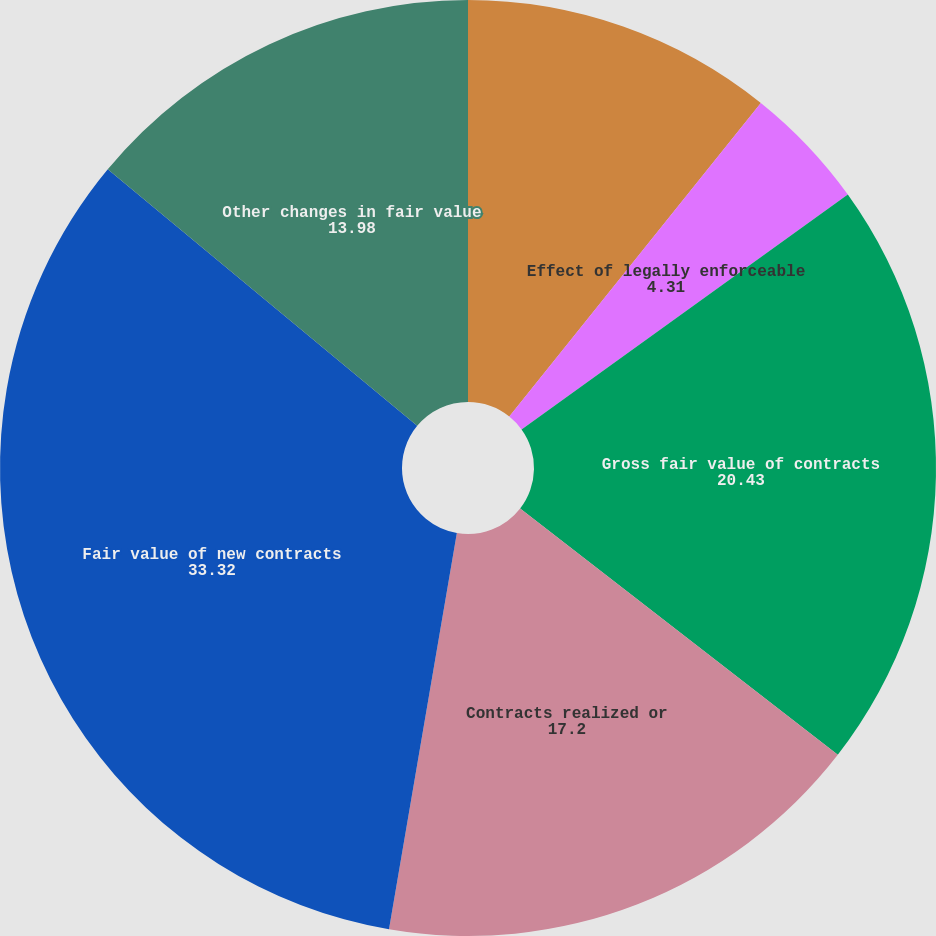Convert chart. <chart><loc_0><loc_0><loc_500><loc_500><pie_chart><fcel>Net fair value of contracts<fcel>Effect of legally enforceable<fcel>Gross fair value of contracts<fcel>Contracts realized or<fcel>Fair value of new contracts<fcel>Other changes in fair value<nl><fcel>10.76%<fcel>4.31%<fcel>20.43%<fcel>17.2%<fcel>33.32%<fcel>13.98%<nl></chart> 